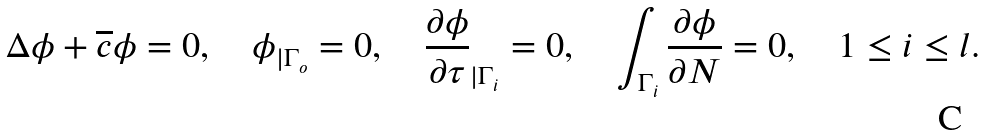<formula> <loc_0><loc_0><loc_500><loc_500>\Delta \phi + \overline { c } \phi = 0 , \quad \phi _ { | \Gamma _ { o } } = 0 , \quad \frac { \partial \phi } { \partial \tau } _ { | \Gamma _ { i } } = 0 , \quad \int _ { \Gamma _ { i } } \frac { \partial \phi } { \partial N } = 0 , \quad 1 \leq i \leq l .</formula> 